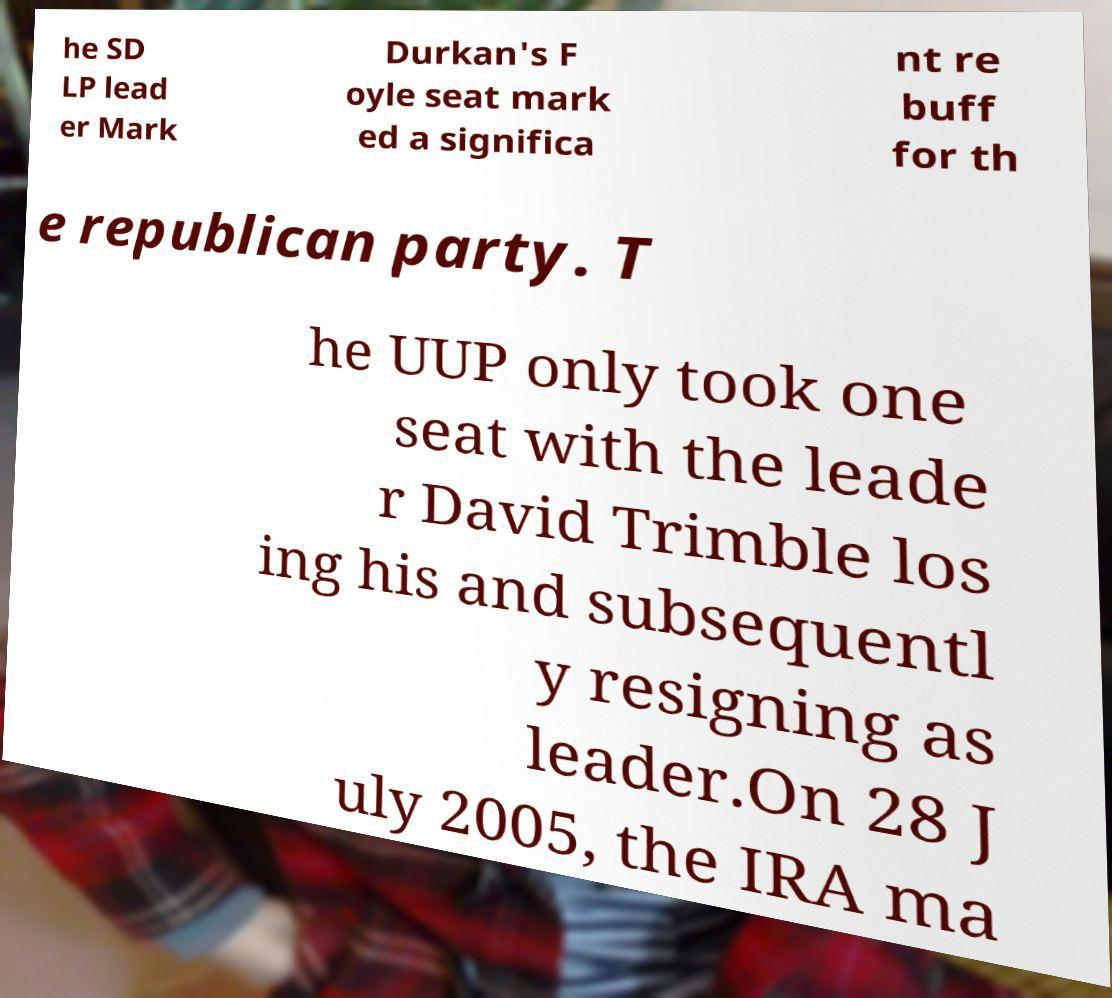I need the written content from this picture converted into text. Can you do that? he SD LP lead er Mark Durkan's F oyle seat mark ed a significa nt re buff for th e republican party. T he UUP only took one seat with the leade r David Trimble los ing his and subsequentl y resigning as leader.On 28 J uly 2005, the IRA ma 